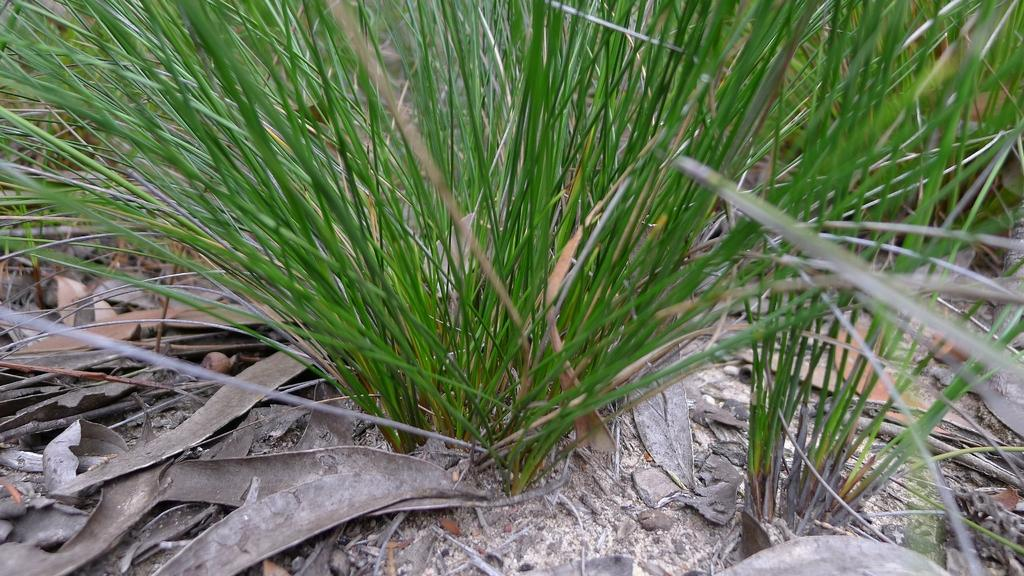What type of vegetation is present in the image? There is grass in the image. Where is the leather faucet located in the image? There is no leather faucet present in the image; it only contains grass. 